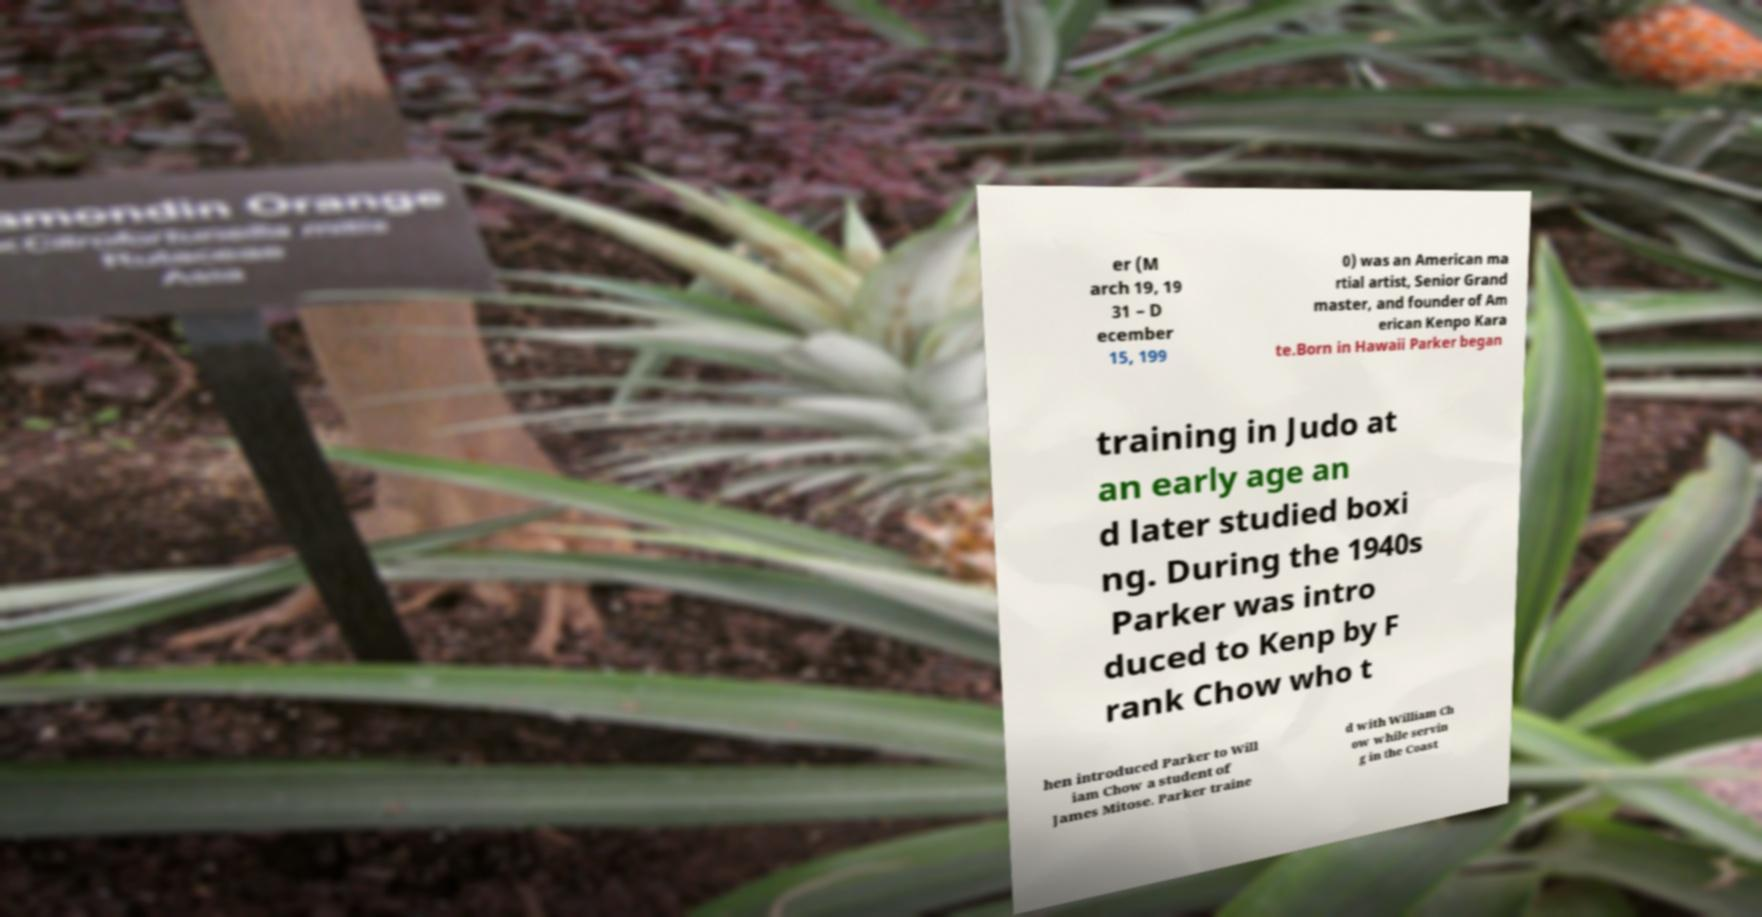Could you extract and type out the text from this image? er (M arch 19, 19 31 – D ecember 15, 199 0) was an American ma rtial artist, Senior Grand master, and founder of Am erican Kenpo Kara te.Born in Hawaii Parker began training in Judo at an early age an d later studied boxi ng. During the 1940s Parker was intro duced to Kenp by F rank Chow who t hen introduced Parker to Will iam Chow a student of James Mitose. Parker traine d with William Ch ow while servin g in the Coast 